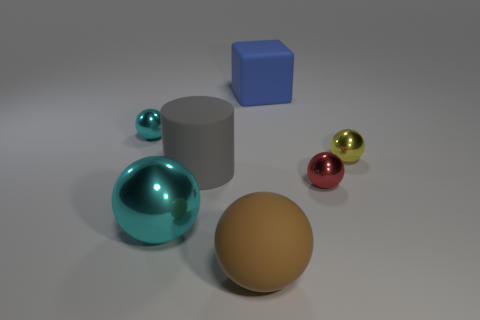Is there any other thing that is the same color as the large cylinder?
Your answer should be compact. No. There is a big thing on the right side of the sphere that is in front of the large sphere that is on the left side of the large brown ball; what shape is it?
Your answer should be very brief. Cube. Is the size of the cyan object behind the big cyan metallic object the same as the cyan thing in front of the gray rubber thing?
Your answer should be compact. No. What number of blue things are made of the same material as the big cylinder?
Offer a terse response. 1. How many tiny metallic things are right of the large sphere left of the large gray cylinder behind the big brown thing?
Your answer should be very brief. 2. Does the tiny cyan metal thing have the same shape as the red metallic thing?
Make the answer very short. Yes. Is there a big gray rubber object of the same shape as the large shiny thing?
Make the answer very short. No. What is the shape of the blue rubber object that is the same size as the rubber cylinder?
Offer a terse response. Cube. What material is the object behind the cyan metallic sphere that is left of the cyan metallic object that is in front of the tiny cyan sphere?
Your answer should be compact. Rubber. Does the red ball have the same size as the gray thing?
Make the answer very short. No. 